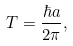<formula> <loc_0><loc_0><loc_500><loc_500>T = \frac { \hbar { a } } { 2 \pi } ,</formula> 